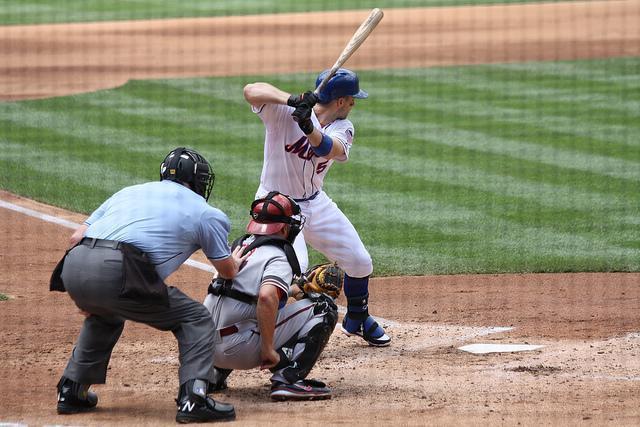What number is the batter?
Choose the correct response and explain in the format: 'Answer: answer
Rationale: rationale.'
Options: Five, 42, 12, nine. Answer: five.
Rationale: It is on the front of his shirt 